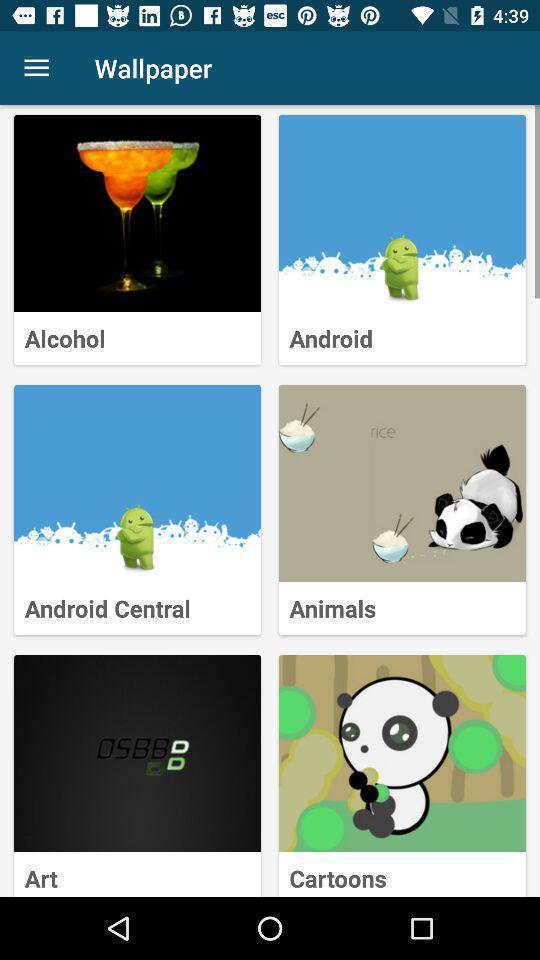What is the overall content of this screenshot? Page displaying list of different image options. 